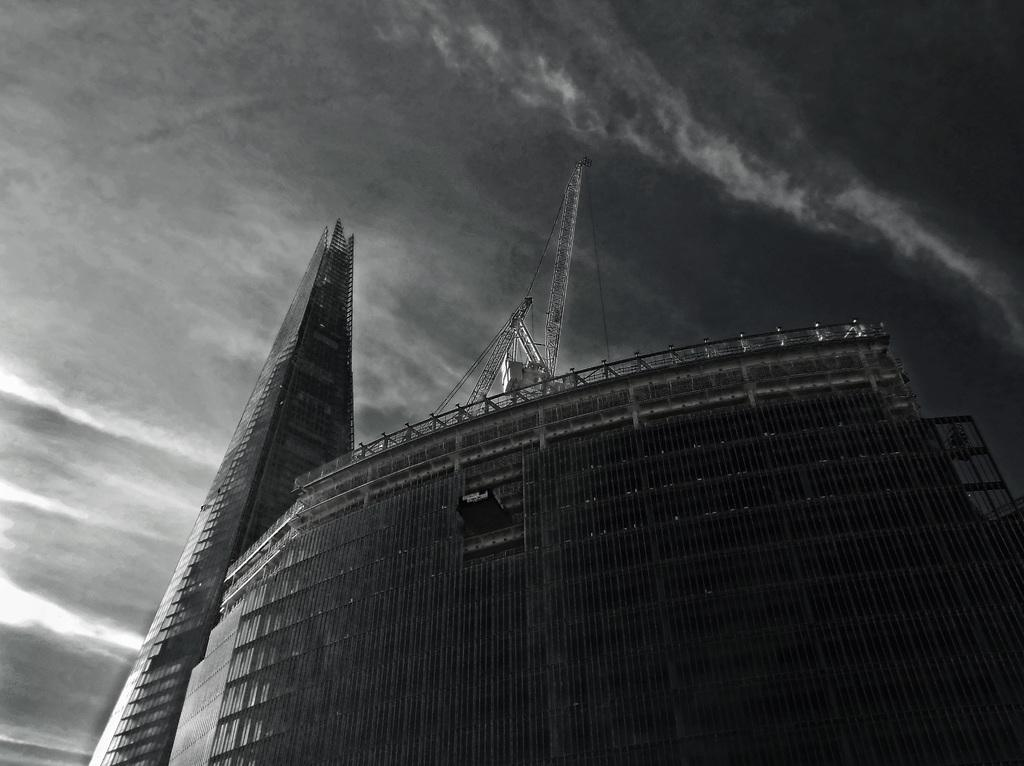What is the color scheme of the image? The image is black and white. What type of structure can be seen in the image? There is a building in the image. What part of the natural environment is visible in the image? The sky is visible in the background of the image. What is the fifth development in the image? There is no reference to multiple developments or a numbered sequence in the image, so it is not possible to answer that question. 